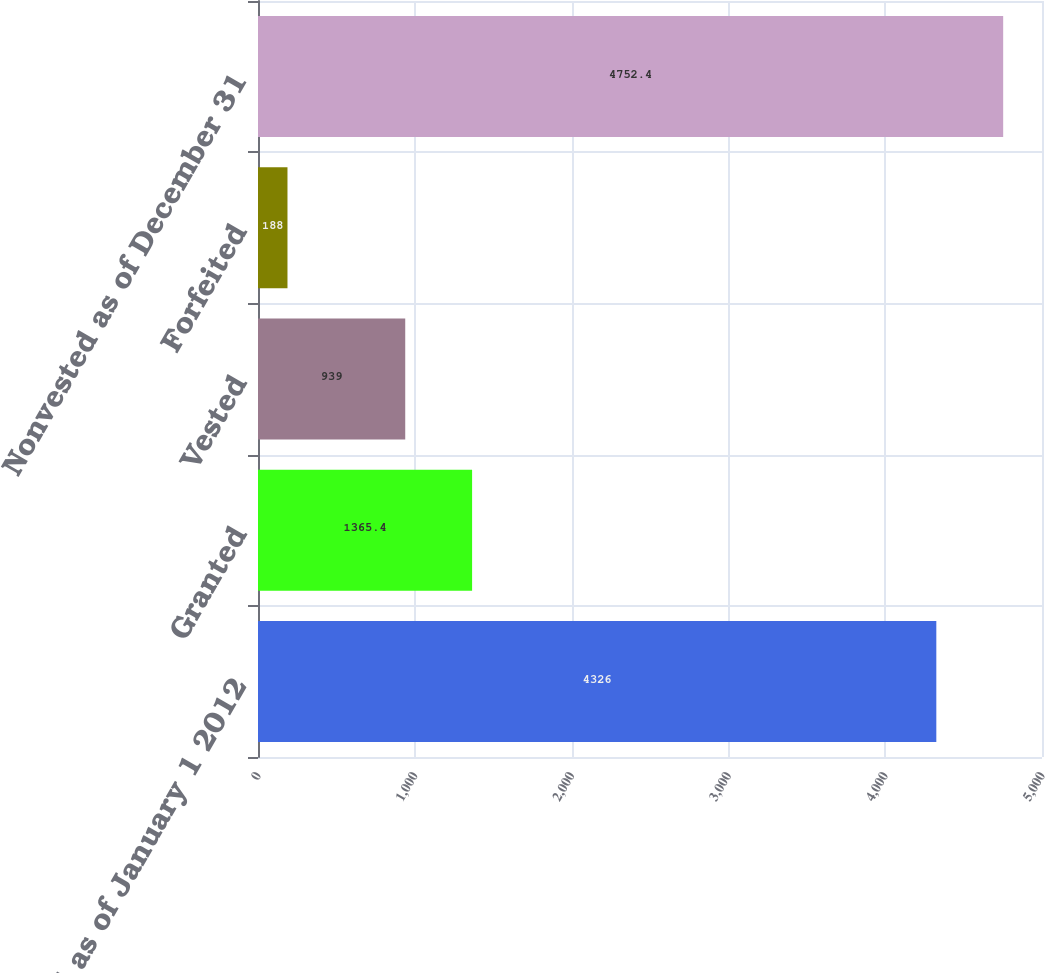Convert chart. <chart><loc_0><loc_0><loc_500><loc_500><bar_chart><fcel>Nonvested as of January 1 2012<fcel>Granted<fcel>Vested<fcel>Forfeited<fcel>Nonvested as of December 31<nl><fcel>4326<fcel>1365.4<fcel>939<fcel>188<fcel>4752.4<nl></chart> 